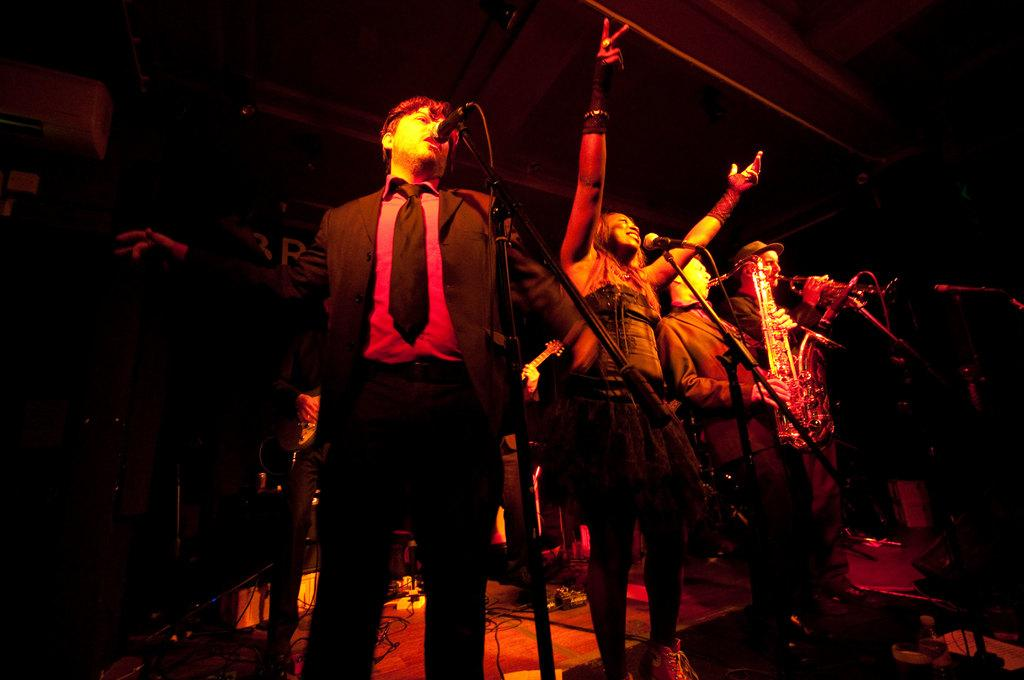What are the people in the image doing? The people in the image are playing musical instruments. What equipment is present to amplify their sound? There are microphones in front of the people playing musical instruments. What can be seen on the floor at the bottom of the image? There are wires on the floor at the bottom of the image. What type of plant is growing on the drum in the image? There is no plant growing on a drum in the image, as there is no drum present. 